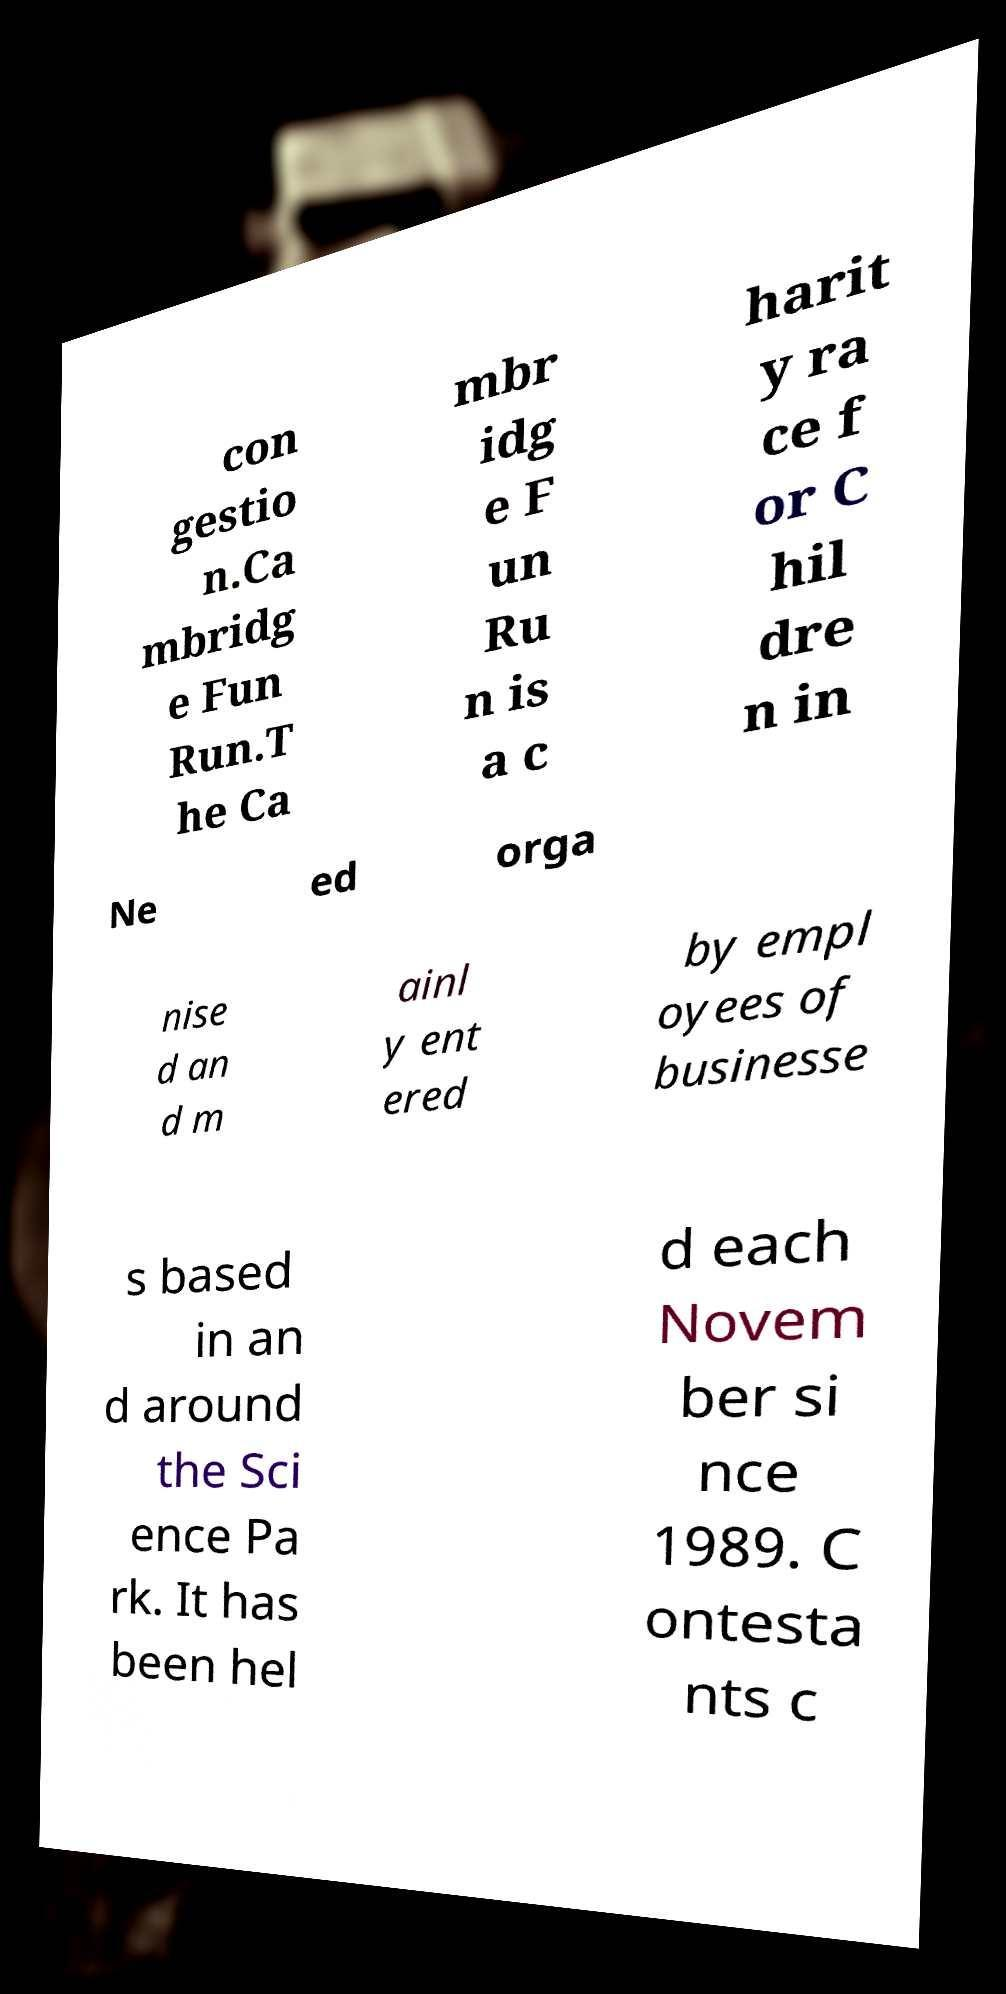Could you assist in decoding the text presented in this image and type it out clearly? con gestio n.Ca mbridg e Fun Run.T he Ca mbr idg e F un Ru n is a c harit y ra ce f or C hil dre n in Ne ed orga nise d an d m ainl y ent ered by empl oyees of businesse s based in an d around the Sci ence Pa rk. It has been hel d each Novem ber si nce 1989. C ontesta nts c 